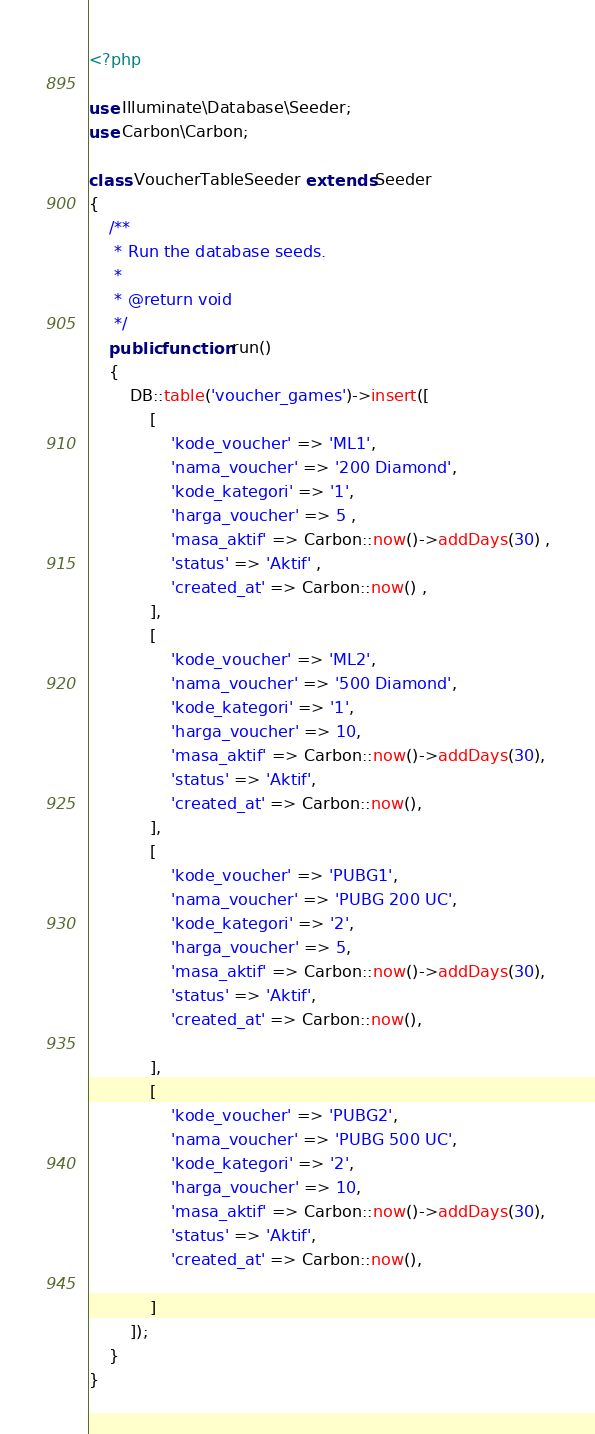Convert code to text. <code><loc_0><loc_0><loc_500><loc_500><_PHP_><?php

use Illuminate\Database\Seeder;
use Carbon\Carbon;

class VoucherTableSeeder extends Seeder
{
    /**
     * Run the database seeds.
     *
     * @return void
     */
    public function run()
    {
        DB::table('voucher_games')->insert([
            [
                'kode_voucher' => 'ML1',
                'nama_voucher' => '200 Diamond',
                'kode_kategori' => '1',
                'harga_voucher' => 5 ,
                'masa_aktif' => Carbon::now()->addDays(30) ,
                'status' => 'Aktif' ,
                'created_at' => Carbon::now() ,
            ],
            [
                'kode_voucher' => 'ML2',
                'nama_voucher' => '500 Diamond',
                'kode_kategori' => '1',
                'harga_voucher' => 10,
                'masa_aktif' => Carbon::now()->addDays(30),
                'status' => 'Aktif',
                'created_at' => Carbon::now(),
            ],
            [
                'kode_voucher' => 'PUBG1',
                'nama_voucher' => 'PUBG 200 UC',
                'kode_kategori' => '2',
                'harga_voucher' => 5,
                'masa_aktif' => Carbon::now()->addDays(30),
                'status' => 'Aktif',
                'created_at' => Carbon::now(),

            ],
            [
                'kode_voucher' => 'PUBG2',
                'nama_voucher' => 'PUBG 500 UC',
                'kode_kategori' => '2',
                'harga_voucher' => 10,
                'masa_aktif' => Carbon::now()->addDays(30),
                'status' => 'Aktif',
                'created_at' => Carbon::now(),

            ]
        ]);
    }
}
</code> 